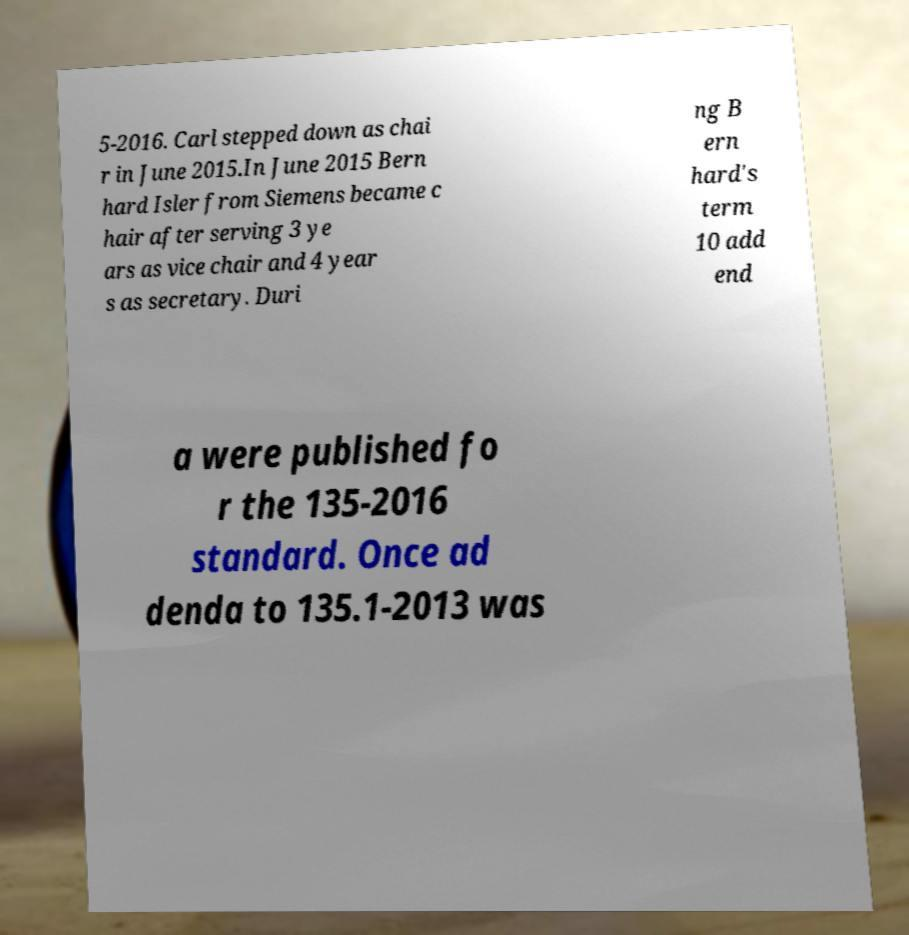Please read and relay the text visible in this image. What does it say? 5-2016. Carl stepped down as chai r in June 2015.In June 2015 Bern hard Isler from Siemens became c hair after serving 3 ye ars as vice chair and 4 year s as secretary. Duri ng B ern hard's term 10 add end a were published fo r the 135-2016 standard. Once ad denda to 135.1-2013 was 